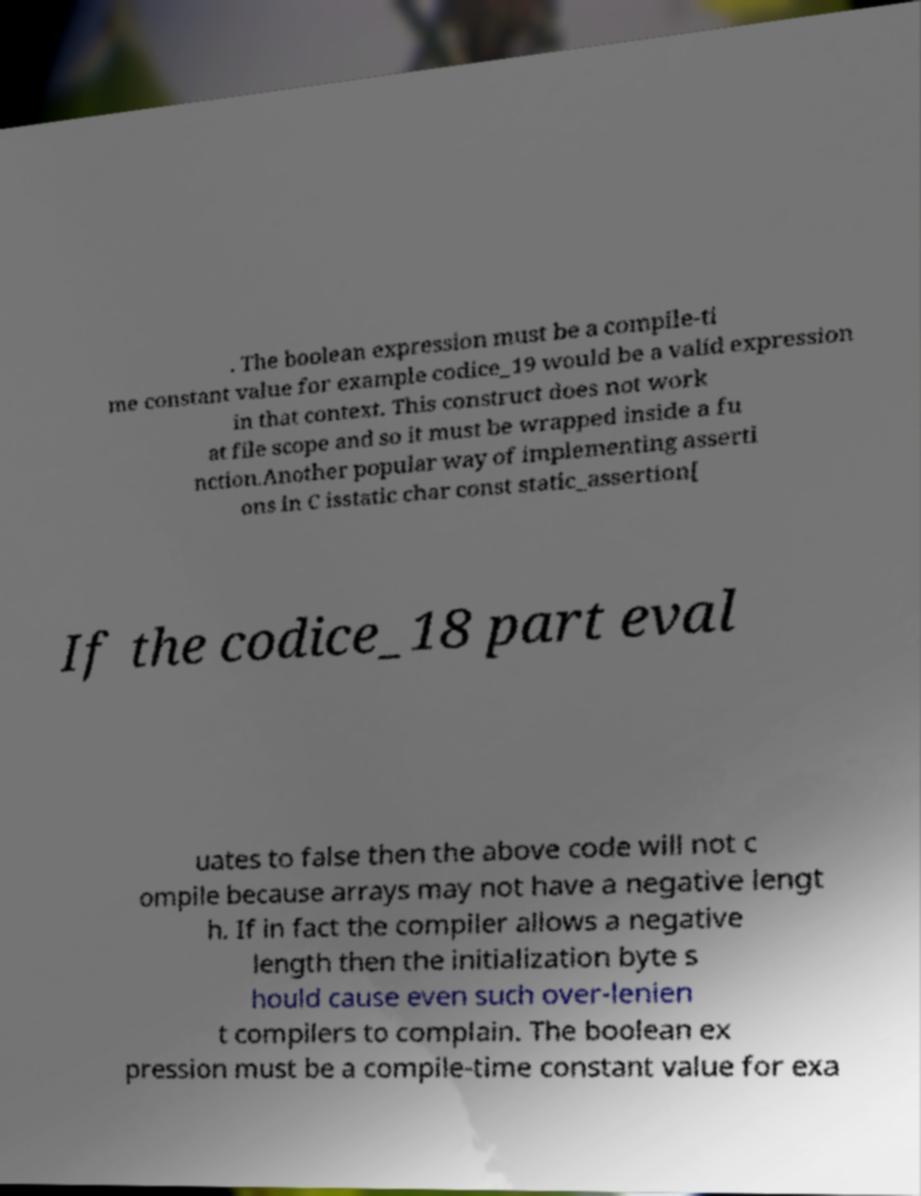Could you assist in decoding the text presented in this image and type it out clearly? . The boolean expression must be a compile-ti me constant value for example codice_19 would be a valid expression in that context. This construct does not work at file scope and so it must be wrapped inside a fu nction.Another popular way of implementing asserti ons in C isstatic char const static_assertion[ If the codice_18 part eval uates to false then the above code will not c ompile because arrays may not have a negative lengt h. If in fact the compiler allows a negative length then the initialization byte s hould cause even such over-lenien t compilers to complain. The boolean ex pression must be a compile-time constant value for exa 